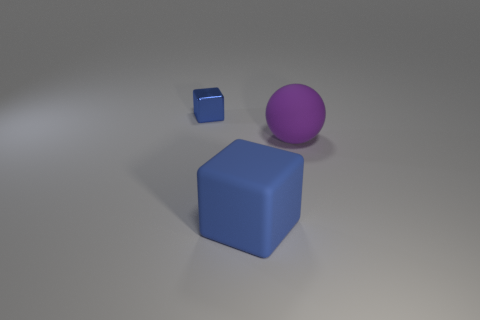Are there the same number of purple things that are to the right of the purple object and cyan blocks?
Offer a very short reply. Yes. There is a object on the right side of the block in front of the ball; what is its material?
Your answer should be compact. Rubber. The metal thing has what shape?
Make the answer very short. Cube. Are there the same number of tiny blue things to the right of the small blue thing and blue matte things that are in front of the large ball?
Offer a terse response. No. There is a big matte thing on the left side of the large purple rubber object; is its color the same as the thing left of the big blue block?
Ensure brevity in your answer.  Yes. Are there more blue blocks that are in front of the purple matte sphere than tiny cyan rubber spheres?
Offer a terse response. Yes. There is a blue thing that is made of the same material as the ball; what is its shape?
Your answer should be very brief. Cube. There is a blue block behind the rubber ball; is its size the same as the big blue thing?
Offer a terse response. No. There is a blue object that is on the right side of the cube that is on the left side of the large blue cube; what is its shape?
Your answer should be compact. Cube. There is a object that is on the left side of the thing that is in front of the purple rubber ball; what is its size?
Offer a very short reply. Small. 